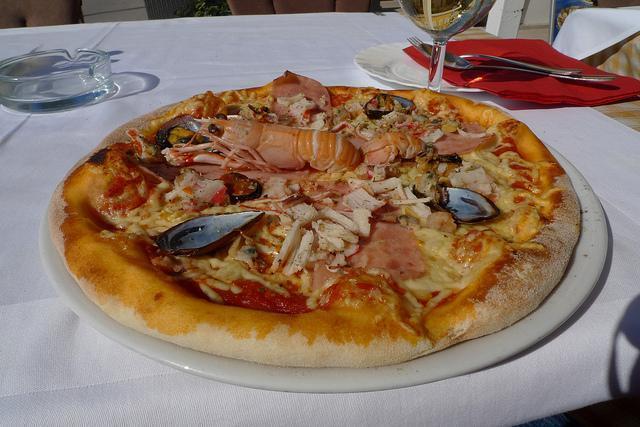How many pizzas are in the photo?
Give a very brief answer. 1. 